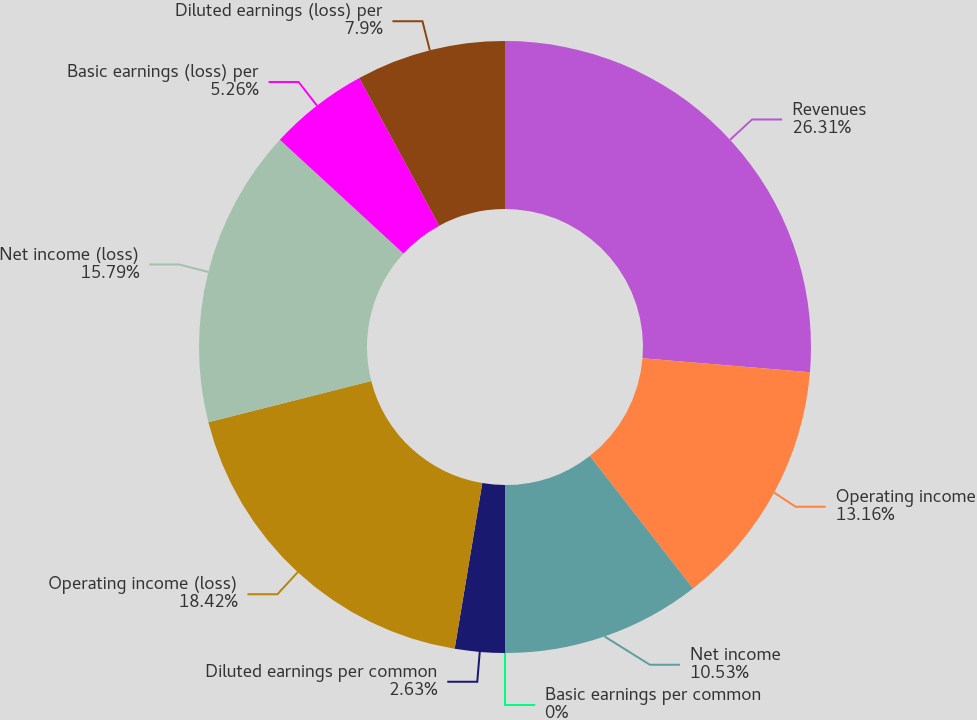Convert chart. <chart><loc_0><loc_0><loc_500><loc_500><pie_chart><fcel>Revenues<fcel>Operating income<fcel>Net income<fcel>Basic earnings per common<fcel>Diluted earnings per common<fcel>Operating income (loss)<fcel>Net income (loss)<fcel>Basic earnings (loss) per<fcel>Diluted earnings (loss) per<nl><fcel>26.31%<fcel>13.16%<fcel>10.53%<fcel>0.0%<fcel>2.63%<fcel>18.42%<fcel>15.79%<fcel>5.26%<fcel>7.9%<nl></chart> 